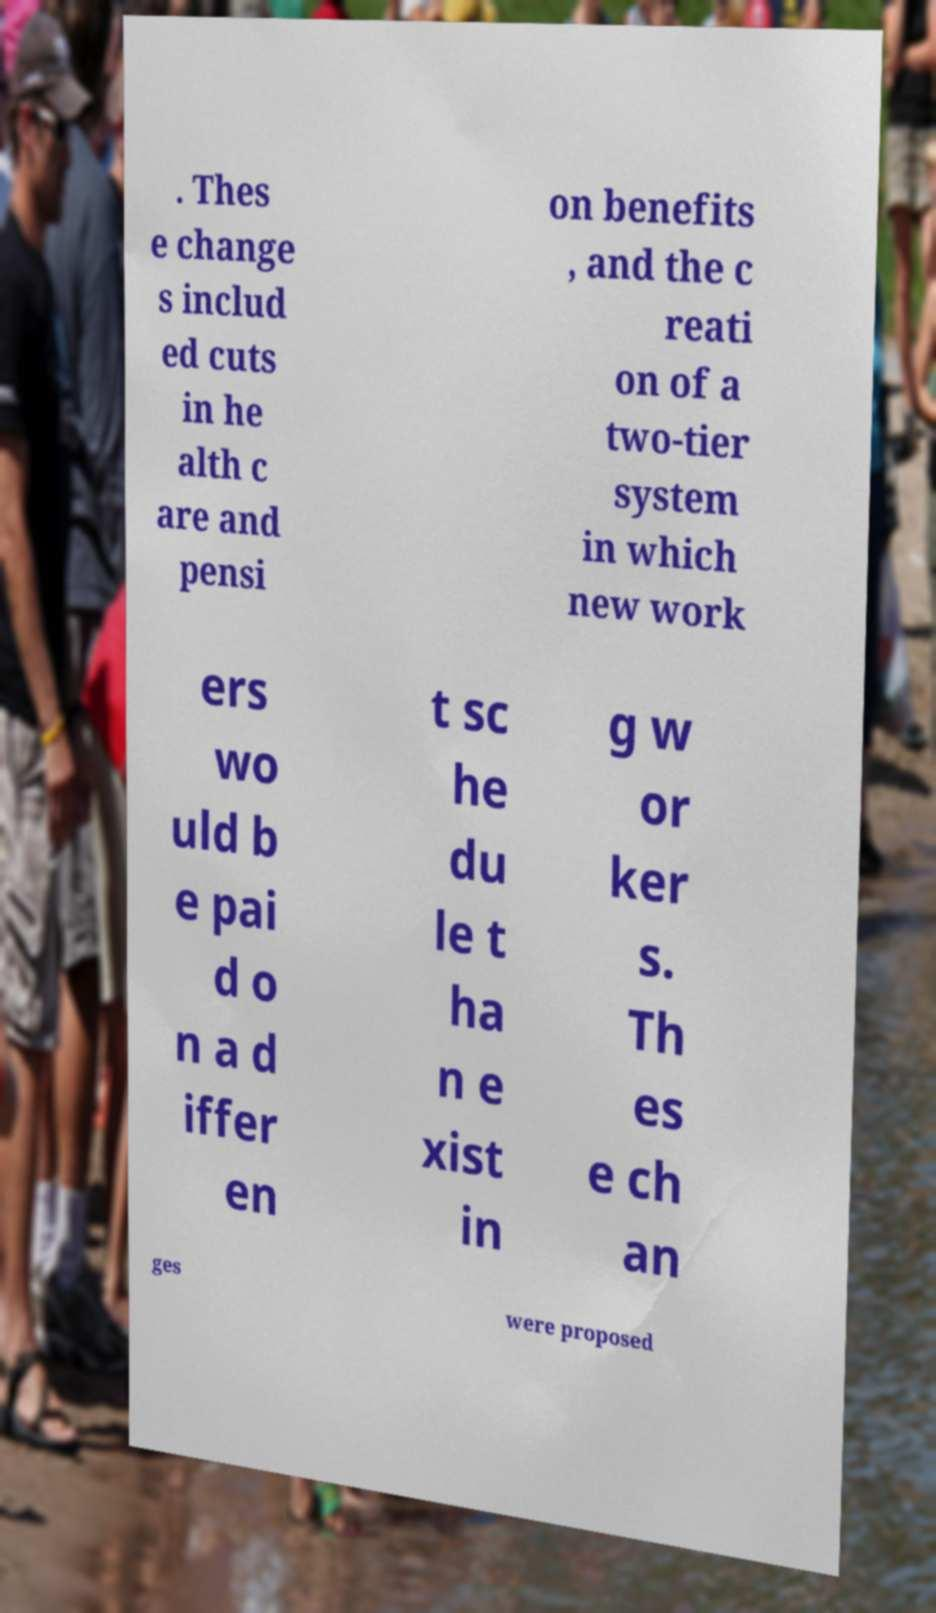I need the written content from this picture converted into text. Can you do that? . Thes e change s includ ed cuts in he alth c are and pensi on benefits , and the c reati on of a two-tier system in which new work ers wo uld b e pai d o n a d iffer en t sc he du le t ha n e xist in g w or ker s. Th es e ch an ges were proposed 